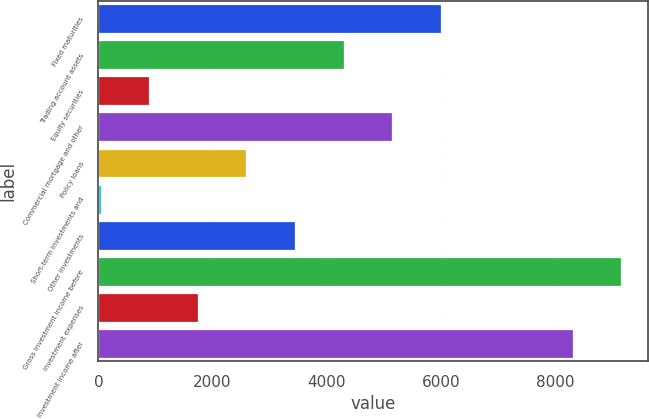Convert chart to OTSL. <chart><loc_0><loc_0><loc_500><loc_500><bar_chart><fcel>Fixed maturities<fcel>Trading account assets<fcel>Equity securities<fcel>Commercial mortgage and other<fcel>Policy loans<fcel>Short-term investments and<fcel>Other investments<fcel>Gross investment income before<fcel>Investment expenses<fcel>Investment income after<nl><fcel>5998.5<fcel>4295.5<fcel>889.5<fcel>5147<fcel>2592.5<fcel>38<fcel>3444<fcel>9165.5<fcel>1741<fcel>8314<nl></chart> 